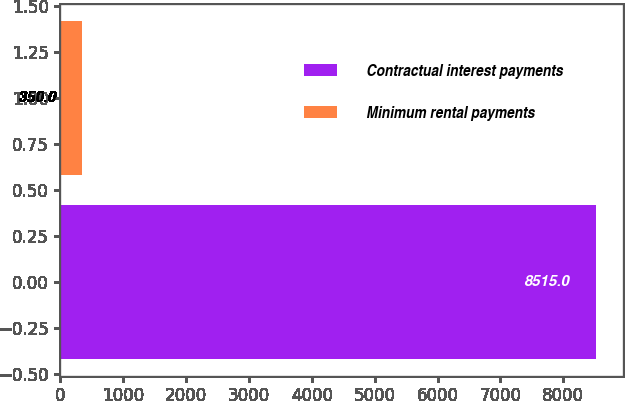<chart> <loc_0><loc_0><loc_500><loc_500><bar_chart><fcel>Contractual interest payments<fcel>Minimum rental payments<nl><fcel>8515<fcel>350<nl></chart> 